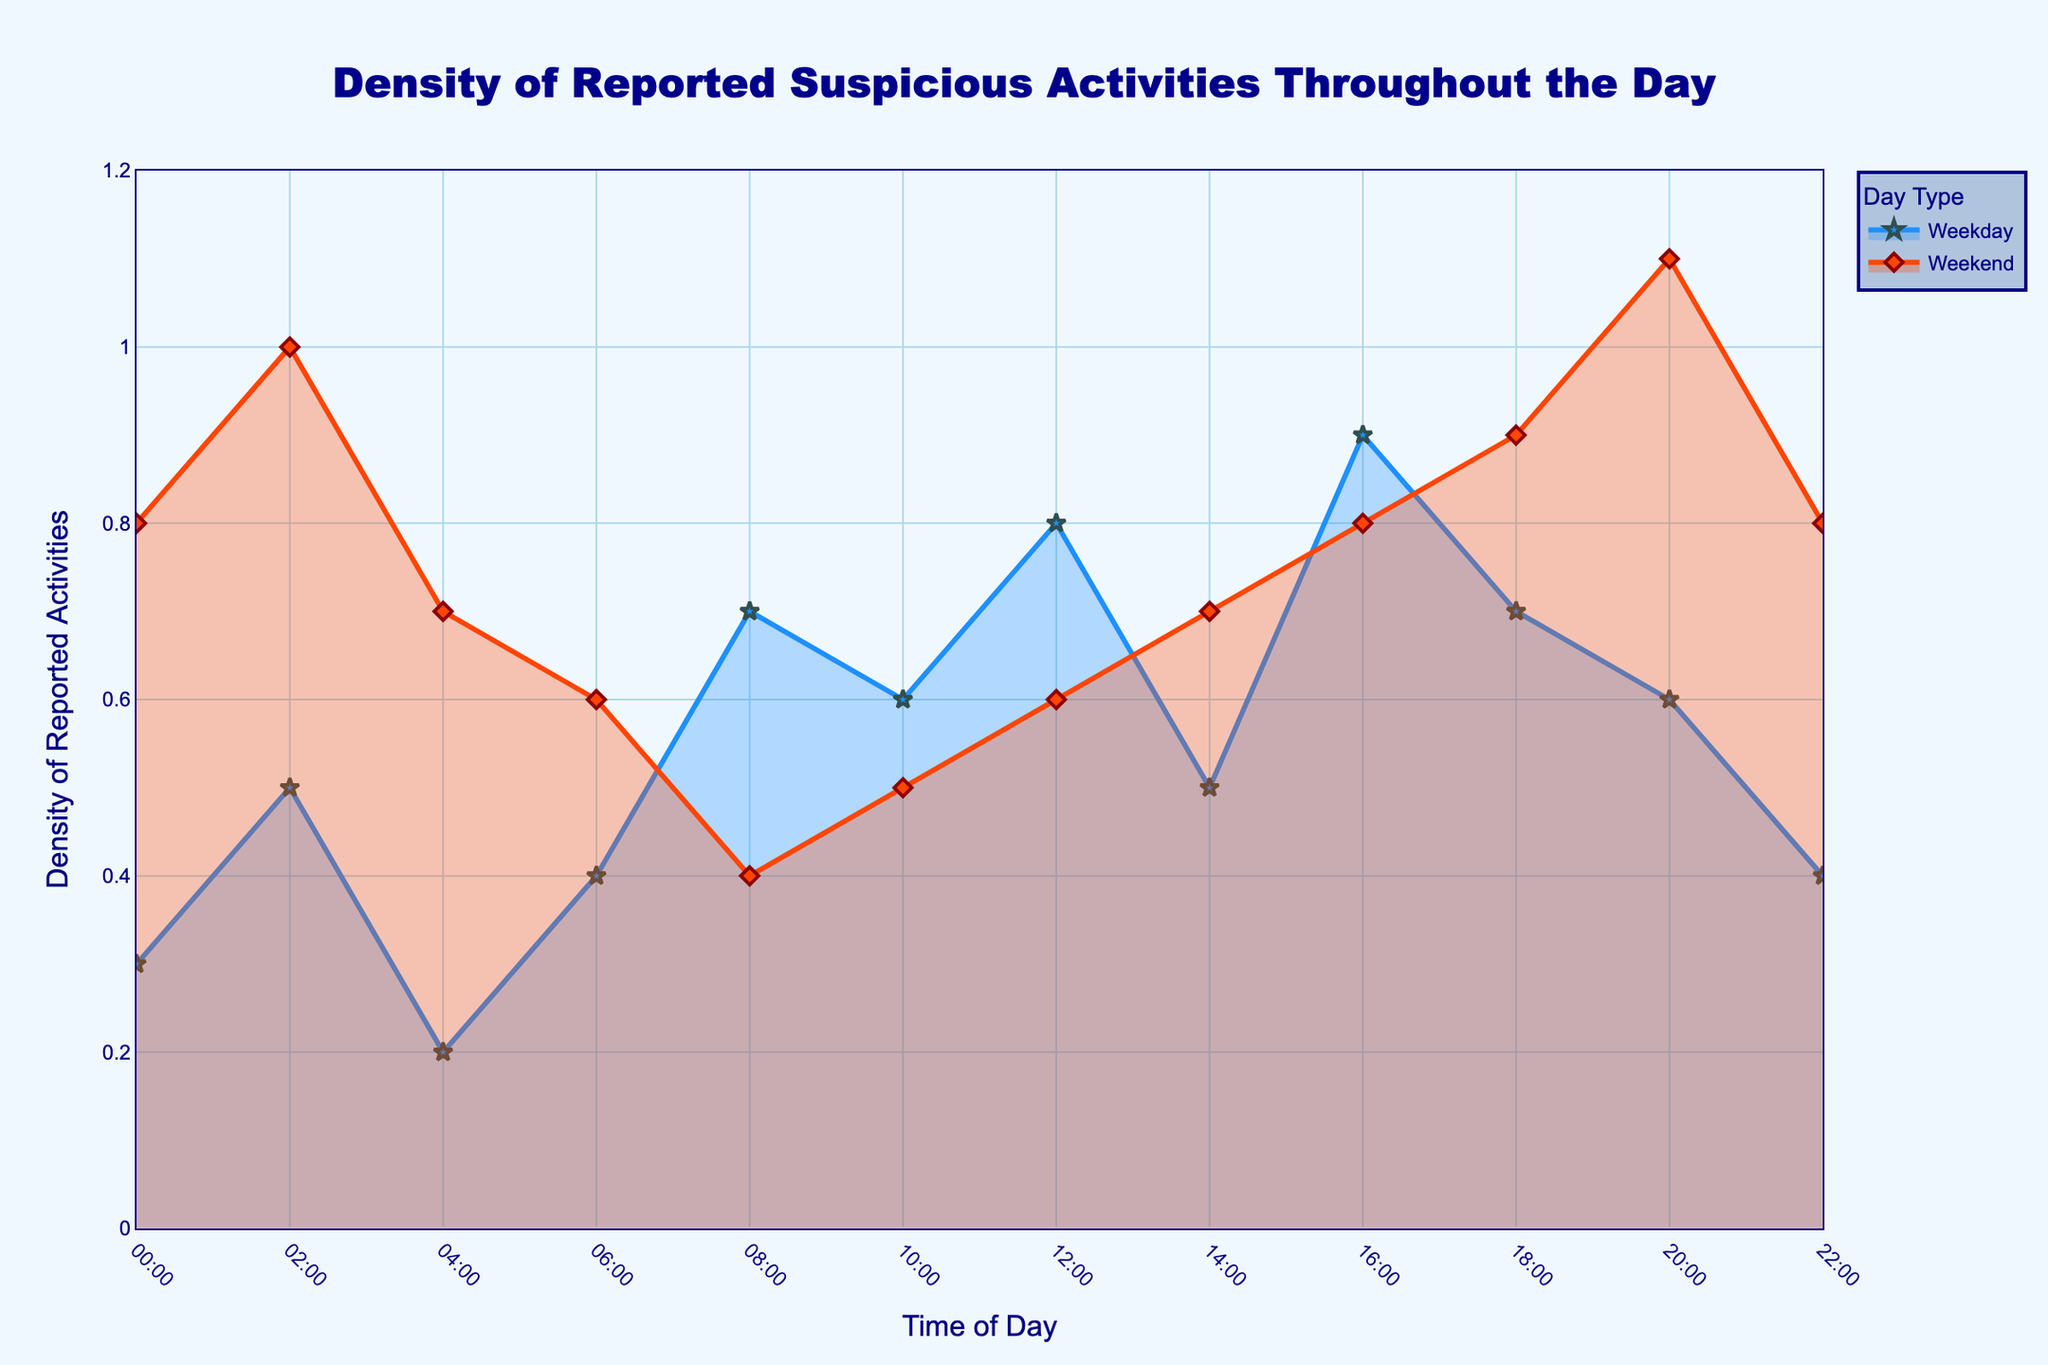What is the title of the figure? The title is usually located at the top of the figure and provides a summary of the content. The title reads "Density of Reported Suspicious Activities Throughout the Day".
Answer: Density of Reported Suspicious Activities Throughout the Day What are the axes labels? The x-axis label shows "Time of Day", and the y-axis label shows "Density of Reported Activities". This information is essential to understand what each axis represents in the plot.
Answer: Time of Day, Density of Reported Activities Which day type has the highest density at 16:00? To determine this, find the data points at 16:00 for both weekday and weekend traces and compare their densities. The weekday has a value of 0.9, and the weekend has a value of 0.8.
Answer: Weekday At what time does weekend activity reach its peak density? Examine the weekend data line to find the time point where the density is the highest. The peak occurs at 20:00 with a density of 1.1.
Answer: 20:00 Which activity has the lowest density on a weekday, and what is the value? Identify the lowest point on the weekday trace. The lowest density is at 04:00 for "noise complaint" with a value of 0.2.
Answer: Noise complaint, 0.2 How does the density of loitering on weekdays compare to public intoxication on weekends at 00:00? Look at the densities at 00:00 for both traces. Loitering on weekdays has a density of 0.3, while public intoxication on weekends has a density of 0.8.
Answer: Loitering on weekdays is less than public intoxication on weekends What is the difference in density for drug activity between weekday and weekend at 16:00? Check the density at 16:00 for both weekday and weekend traces. Weekday density is 0.9, while weekend density is 0.8. The difference is 0.9 - 0.8 = 0.1.
Answer: 0.1 On weekends, which activity peaks at 02:00, and what is the density value? Find the data point at 02:00 on the weekend trace. The activity "bar fights" peaks with a density of 1.0.
Answer: Bar fights, 1.0 During which time period does the density of suspicious activity remain consistently high for both weekdays and weekends? Examine both traces to find overlapping time periods with high densities. Both weekdays and weekends show high densities from 16:00 to 20:00.
Answer: 16:00 to 20:00 